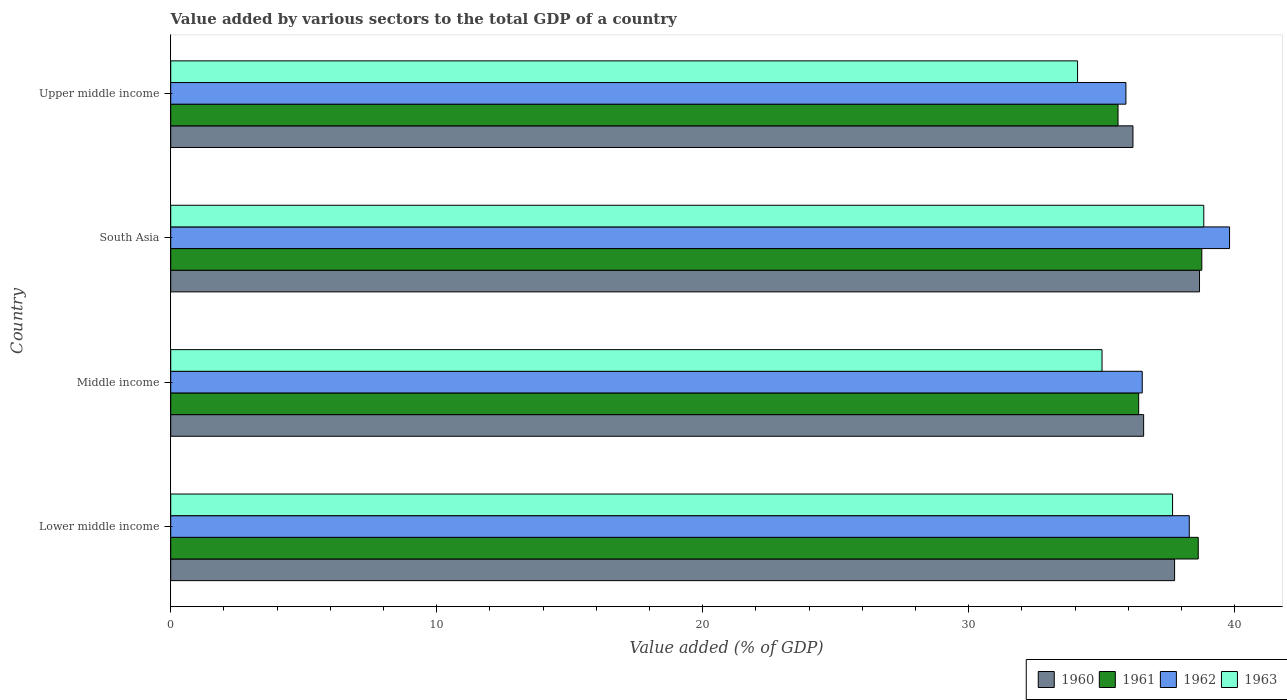How many different coloured bars are there?
Your answer should be very brief. 4. Are the number of bars per tick equal to the number of legend labels?
Your answer should be very brief. Yes. How many bars are there on the 1st tick from the bottom?
Your answer should be very brief. 4. What is the label of the 4th group of bars from the top?
Provide a short and direct response. Lower middle income. What is the value added by various sectors to the total GDP in 1961 in Upper middle income?
Keep it short and to the point. 35.61. Across all countries, what is the maximum value added by various sectors to the total GDP in 1960?
Offer a very short reply. 38.68. Across all countries, what is the minimum value added by various sectors to the total GDP in 1961?
Give a very brief answer. 35.61. In which country was the value added by various sectors to the total GDP in 1962 minimum?
Your response must be concise. Upper middle income. What is the total value added by various sectors to the total GDP in 1962 in the graph?
Your response must be concise. 150.53. What is the difference between the value added by various sectors to the total GDP in 1960 in Middle income and that in Upper middle income?
Provide a succinct answer. 0.4. What is the difference between the value added by various sectors to the total GDP in 1960 in Middle income and the value added by various sectors to the total GDP in 1962 in Upper middle income?
Ensure brevity in your answer.  0.67. What is the average value added by various sectors to the total GDP in 1961 per country?
Offer a terse response. 37.35. What is the difference between the value added by various sectors to the total GDP in 1961 and value added by various sectors to the total GDP in 1960 in Middle income?
Provide a short and direct response. -0.19. What is the ratio of the value added by various sectors to the total GDP in 1960 in Middle income to that in Upper middle income?
Ensure brevity in your answer.  1.01. Is the difference between the value added by various sectors to the total GDP in 1961 in Middle income and South Asia greater than the difference between the value added by various sectors to the total GDP in 1960 in Middle income and South Asia?
Your answer should be very brief. No. What is the difference between the highest and the second highest value added by various sectors to the total GDP in 1963?
Ensure brevity in your answer.  1.17. What is the difference between the highest and the lowest value added by various sectors to the total GDP in 1963?
Give a very brief answer. 4.74. In how many countries, is the value added by various sectors to the total GDP in 1962 greater than the average value added by various sectors to the total GDP in 1962 taken over all countries?
Offer a very short reply. 2. Is the sum of the value added by various sectors to the total GDP in 1963 in Lower middle income and Upper middle income greater than the maximum value added by various sectors to the total GDP in 1960 across all countries?
Provide a succinct answer. Yes. Is it the case that in every country, the sum of the value added by various sectors to the total GDP in 1963 and value added by various sectors to the total GDP in 1961 is greater than the sum of value added by various sectors to the total GDP in 1962 and value added by various sectors to the total GDP in 1960?
Provide a short and direct response. No. Are all the bars in the graph horizontal?
Your answer should be very brief. Yes. Does the graph contain any zero values?
Make the answer very short. No. Where does the legend appear in the graph?
Keep it short and to the point. Bottom right. How many legend labels are there?
Make the answer very short. 4. How are the legend labels stacked?
Ensure brevity in your answer.  Horizontal. What is the title of the graph?
Your answer should be very brief. Value added by various sectors to the total GDP of a country. Does "2009" appear as one of the legend labels in the graph?
Provide a succinct answer. No. What is the label or title of the X-axis?
Your answer should be very brief. Value added (% of GDP). What is the label or title of the Y-axis?
Your response must be concise. Country. What is the Value added (% of GDP) in 1960 in Lower middle income?
Offer a very short reply. 37.74. What is the Value added (% of GDP) in 1961 in Lower middle income?
Your answer should be very brief. 38.63. What is the Value added (% of GDP) of 1962 in Lower middle income?
Your answer should be very brief. 38.29. What is the Value added (% of GDP) in 1963 in Lower middle income?
Your response must be concise. 37.66. What is the Value added (% of GDP) in 1960 in Middle income?
Offer a terse response. 36.58. What is the Value added (% of GDP) of 1961 in Middle income?
Provide a succinct answer. 36.39. What is the Value added (% of GDP) of 1962 in Middle income?
Your response must be concise. 36.52. What is the Value added (% of GDP) of 1963 in Middle income?
Make the answer very short. 35.01. What is the Value added (% of GDP) in 1960 in South Asia?
Give a very brief answer. 38.68. What is the Value added (% of GDP) of 1961 in South Asia?
Your answer should be compact. 38.76. What is the Value added (% of GDP) in 1962 in South Asia?
Give a very brief answer. 39.81. What is the Value added (% of GDP) in 1963 in South Asia?
Offer a terse response. 38.84. What is the Value added (% of GDP) of 1960 in Upper middle income?
Give a very brief answer. 36.17. What is the Value added (% of GDP) of 1961 in Upper middle income?
Give a very brief answer. 35.61. What is the Value added (% of GDP) of 1962 in Upper middle income?
Your answer should be compact. 35.91. What is the Value added (% of GDP) of 1963 in Upper middle income?
Ensure brevity in your answer.  34.09. Across all countries, what is the maximum Value added (% of GDP) in 1960?
Your response must be concise. 38.68. Across all countries, what is the maximum Value added (% of GDP) in 1961?
Ensure brevity in your answer.  38.76. Across all countries, what is the maximum Value added (% of GDP) of 1962?
Provide a short and direct response. 39.81. Across all countries, what is the maximum Value added (% of GDP) of 1963?
Provide a short and direct response. 38.84. Across all countries, what is the minimum Value added (% of GDP) in 1960?
Keep it short and to the point. 36.17. Across all countries, what is the minimum Value added (% of GDP) of 1961?
Make the answer very short. 35.61. Across all countries, what is the minimum Value added (% of GDP) of 1962?
Provide a short and direct response. 35.91. Across all countries, what is the minimum Value added (% of GDP) of 1963?
Give a very brief answer. 34.09. What is the total Value added (% of GDP) of 1960 in the graph?
Keep it short and to the point. 149.17. What is the total Value added (% of GDP) in 1961 in the graph?
Make the answer very short. 149.39. What is the total Value added (% of GDP) of 1962 in the graph?
Provide a short and direct response. 150.53. What is the total Value added (% of GDP) of 1963 in the graph?
Give a very brief answer. 145.6. What is the difference between the Value added (% of GDP) in 1960 in Lower middle income and that in Middle income?
Make the answer very short. 1.16. What is the difference between the Value added (% of GDP) of 1961 in Lower middle income and that in Middle income?
Give a very brief answer. 2.24. What is the difference between the Value added (% of GDP) in 1962 in Lower middle income and that in Middle income?
Your answer should be very brief. 1.77. What is the difference between the Value added (% of GDP) of 1963 in Lower middle income and that in Middle income?
Offer a very short reply. 2.65. What is the difference between the Value added (% of GDP) in 1960 in Lower middle income and that in South Asia?
Offer a very short reply. -0.94. What is the difference between the Value added (% of GDP) of 1961 in Lower middle income and that in South Asia?
Provide a short and direct response. -0.13. What is the difference between the Value added (% of GDP) in 1962 in Lower middle income and that in South Asia?
Offer a terse response. -1.51. What is the difference between the Value added (% of GDP) in 1963 in Lower middle income and that in South Asia?
Offer a very short reply. -1.17. What is the difference between the Value added (% of GDP) of 1960 in Lower middle income and that in Upper middle income?
Offer a terse response. 1.57. What is the difference between the Value added (% of GDP) in 1961 in Lower middle income and that in Upper middle income?
Provide a succinct answer. 3.02. What is the difference between the Value added (% of GDP) in 1962 in Lower middle income and that in Upper middle income?
Give a very brief answer. 2.38. What is the difference between the Value added (% of GDP) of 1963 in Lower middle income and that in Upper middle income?
Your answer should be very brief. 3.57. What is the difference between the Value added (% of GDP) of 1960 in Middle income and that in South Asia?
Your answer should be very brief. -2.1. What is the difference between the Value added (% of GDP) in 1961 in Middle income and that in South Asia?
Keep it short and to the point. -2.37. What is the difference between the Value added (% of GDP) of 1962 in Middle income and that in South Asia?
Make the answer very short. -3.28. What is the difference between the Value added (% of GDP) in 1963 in Middle income and that in South Asia?
Your answer should be compact. -3.83. What is the difference between the Value added (% of GDP) in 1960 in Middle income and that in Upper middle income?
Ensure brevity in your answer.  0.4. What is the difference between the Value added (% of GDP) in 1961 in Middle income and that in Upper middle income?
Your response must be concise. 0.78. What is the difference between the Value added (% of GDP) in 1962 in Middle income and that in Upper middle income?
Keep it short and to the point. 0.61. What is the difference between the Value added (% of GDP) of 1963 in Middle income and that in Upper middle income?
Your response must be concise. 0.92. What is the difference between the Value added (% of GDP) in 1960 in South Asia and that in Upper middle income?
Make the answer very short. 2.5. What is the difference between the Value added (% of GDP) of 1961 in South Asia and that in Upper middle income?
Keep it short and to the point. 3.15. What is the difference between the Value added (% of GDP) of 1962 in South Asia and that in Upper middle income?
Your answer should be very brief. 3.9. What is the difference between the Value added (% of GDP) of 1963 in South Asia and that in Upper middle income?
Offer a terse response. 4.74. What is the difference between the Value added (% of GDP) of 1960 in Lower middle income and the Value added (% of GDP) of 1961 in Middle income?
Offer a very short reply. 1.35. What is the difference between the Value added (% of GDP) of 1960 in Lower middle income and the Value added (% of GDP) of 1962 in Middle income?
Provide a succinct answer. 1.22. What is the difference between the Value added (% of GDP) of 1960 in Lower middle income and the Value added (% of GDP) of 1963 in Middle income?
Give a very brief answer. 2.73. What is the difference between the Value added (% of GDP) in 1961 in Lower middle income and the Value added (% of GDP) in 1962 in Middle income?
Make the answer very short. 2.11. What is the difference between the Value added (% of GDP) of 1961 in Lower middle income and the Value added (% of GDP) of 1963 in Middle income?
Ensure brevity in your answer.  3.62. What is the difference between the Value added (% of GDP) in 1962 in Lower middle income and the Value added (% of GDP) in 1963 in Middle income?
Your answer should be very brief. 3.28. What is the difference between the Value added (% of GDP) of 1960 in Lower middle income and the Value added (% of GDP) of 1961 in South Asia?
Your answer should be compact. -1.02. What is the difference between the Value added (% of GDP) in 1960 in Lower middle income and the Value added (% of GDP) in 1962 in South Asia?
Give a very brief answer. -2.07. What is the difference between the Value added (% of GDP) in 1960 in Lower middle income and the Value added (% of GDP) in 1963 in South Asia?
Offer a very short reply. -1.1. What is the difference between the Value added (% of GDP) of 1961 in Lower middle income and the Value added (% of GDP) of 1962 in South Asia?
Offer a very short reply. -1.18. What is the difference between the Value added (% of GDP) in 1961 in Lower middle income and the Value added (% of GDP) in 1963 in South Asia?
Offer a terse response. -0.21. What is the difference between the Value added (% of GDP) in 1962 in Lower middle income and the Value added (% of GDP) in 1963 in South Asia?
Your response must be concise. -0.55. What is the difference between the Value added (% of GDP) of 1960 in Lower middle income and the Value added (% of GDP) of 1961 in Upper middle income?
Make the answer very short. 2.13. What is the difference between the Value added (% of GDP) of 1960 in Lower middle income and the Value added (% of GDP) of 1962 in Upper middle income?
Offer a very short reply. 1.83. What is the difference between the Value added (% of GDP) in 1960 in Lower middle income and the Value added (% of GDP) in 1963 in Upper middle income?
Your answer should be compact. 3.65. What is the difference between the Value added (% of GDP) in 1961 in Lower middle income and the Value added (% of GDP) in 1962 in Upper middle income?
Keep it short and to the point. 2.72. What is the difference between the Value added (% of GDP) of 1961 in Lower middle income and the Value added (% of GDP) of 1963 in Upper middle income?
Keep it short and to the point. 4.54. What is the difference between the Value added (% of GDP) of 1962 in Lower middle income and the Value added (% of GDP) of 1963 in Upper middle income?
Your answer should be very brief. 4.2. What is the difference between the Value added (% of GDP) in 1960 in Middle income and the Value added (% of GDP) in 1961 in South Asia?
Offer a very short reply. -2.19. What is the difference between the Value added (% of GDP) of 1960 in Middle income and the Value added (% of GDP) of 1962 in South Asia?
Your answer should be very brief. -3.23. What is the difference between the Value added (% of GDP) in 1960 in Middle income and the Value added (% of GDP) in 1963 in South Asia?
Make the answer very short. -2.26. What is the difference between the Value added (% of GDP) of 1961 in Middle income and the Value added (% of GDP) of 1962 in South Asia?
Offer a terse response. -3.42. What is the difference between the Value added (% of GDP) of 1961 in Middle income and the Value added (% of GDP) of 1963 in South Asia?
Offer a very short reply. -2.45. What is the difference between the Value added (% of GDP) in 1962 in Middle income and the Value added (% of GDP) in 1963 in South Asia?
Make the answer very short. -2.31. What is the difference between the Value added (% of GDP) of 1960 in Middle income and the Value added (% of GDP) of 1961 in Upper middle income?
Your answer should be compact. 0.96. What is the difference between the Value added (% of GDP) in 1960 in Middle income and the Value added (% of GDP) in 1962 in Upper middle income?
Provide a succinct answer. 0.67. What is the difference between the Value added (% of GDP) of 1960 in Middle income and the Value added (% of GDP) of 1963 in Upper middle income?
Make the answer very short. 2.48. What is the difference between the Value added (% of GDP) in 1961 in Middle income and the Value added (% of GDP) in 1962 in Upper middle income?
Keep it short and to the point. 0.48. What is the difference between the Value added (% of GDP) of 1961 in Middle income and the Value added (% of GDP) of 1963 in Upper middle income?
Your answer should be very brief. 2.3. What is the difference between the Value added (% of GDP) of 1962 in Middle income and the Value added (% of GDP) of 1963 in Upper middle income?
Your response must be concise. 2.43. What is the difference between the Value added (% of GDP) in 1960 in South Asia and the Value added (% of GDP) in 1961 in Upper middle income?
Your answer should be very brief. 3.06. What is the difference between the Value added (% of GDP) of 1960 in South Asia and the Value added (% of GDP) of 1962 in Upper middle income?
Your response must be concise. 2.77. What is the difference between the Value added (% of GDP) of 1960 in South Asia and the Value added (% of GDP) of 1963 in Upper middle income?
Provide a short and direct response. 4.58. What is the difference between the Value added (% of GDP) in 1961 in South Asia and the Value added (% of GDP) in 1962 in Upper middle income?
Ensure brevity in your answer.  2.85. What is the difference between the Value added (% of GDP) of 1961 in South Asia and the Value added (% of GDP) of 1963 in Upper middle income?
Your answer should be very brief. 4.67. What is the difference between the Value added (% of GDP) in 1962 in South Asia and the Value added (% of GDP) in 1963 in Upper middle income?
Keep it short and to the point. 5.71. What is the average Value added (% of GDP) of 1960 per country?
Offer a terse response. 37.29. What is the average Value added (% of GDP) of 1961 per country?
Keep it short and to the point. 37.35. What is the average Value added (% of GDP) of 1962 per country?
Make the answer very short. 37.63. What is the average Value added (% of GDP) of 1963 per country?
Keep it short and to the point. 36.4. What is the difference between the Value added (% of GDP) of 1960 and Value added (% of GDP) of 1961 in Lower middle income?
Make the answer very short. -0.89. What is the difference between the Value added (% of GDP) of 1960 and Value added (% of GDP) of 1962 in Lower middle income?
Your answer should be very brief. -0.55. What is the difference between the Value added (% of GDP) of 1960 and Value added (% of GDP) of 1963 in Lower middle income?
Keep it short and to the point. 0.08. What is the difference between the Value added (% of GDP) of 1961 and Value added (% of GDP) of 1962 in Lower middle income?
Provide a succinct answer. 0.34. What is the difference between the Value added (% of GDP) in 1961 and Value added (% of GDP) in 1963 in Lower middle income?
Your answer should be very brief. 0.97. What is the difference between the Value added (% of GDP) in 1962 and Value added (% of GDP) in 1963 in Lower middle income?
Keep it short and to the point. 0.63. What is the difference between the Value added (% of GDP) of 1960 and Value added (% of GDP) of 1961 in Middle income?
Your answer should be very brief. 0.19. What is the difference between the Value added (% of GDP) in 1960 and Value added (% of GDP) in 1962 in Middle income?
Provide a short and direct response. 0.05. What is the difference between the Value added (% of GDP) in 1960 and Value added (% of GDP) in 1963 in Middle income?
Ensure brevity in your answer.  1.56. What is the difference between the Value added (% of GDP) of 1961 and Value added (% of GDP) of 1962 in Middle income?
Provide a short and direct response. -0.13. What is the difference between the Value added (% of GDP) of 1961 and Value added (% of GDP) of 1963 in Middle income?
Provide a succinct answer. 1.38. What is the difference between the Value added (% of GDP) of 1962 and Value added (% of GDP) of 1963 in Middle income?
Make the answer very short. 1.51. What is the difference between the Value added (% of GDP) in 1960 and Value added (% of GDP) in 1961 in South Asia?
Make the answer very short. -0.09. What is the difference between the Value added (% of GDP) in 1960 and Value added (% of GDP) in 1962 in South Asia?
Provide a short and direct response. -1.13. What is the difference between the Value added (% of GDP) of 1960 and Value added (% of GDP) of 1963 in South Asia?
Offer a very short reply. -0.16. What is the difference between the Value added (% of GDP) of 1961 and Value added (% of GDP) of 1962 in South Asia?
Offer a very short reply. -1.04. What is the difference between the Value added (% of GDP) in 1961 and Value added (% of GDP) in 1963 in South Asia?
Offer a very short reply. -0.07. What is the difference between the Value added (% of GDP) in 1962 and Value added (% of GDP) in 1963 in South Asia?
Offer a terse response. 0.97. What is the difference between the Value added (% of GDP) of 1960 and Value added (% of GDP) of 1961 in Upper middle income?
Your response must be concise. 0.56. What is the difference between the Value added (% of GDP) in 1960 and Value added (% of GDP) in 1962 in Upper middle income?
Keep it short and to the point. 0.26. What is the difference between the Value added (% of GDP) in 1960 and Value added (% of GDP) in 1963 in Upper middle income?
Your answer should be very brief. 2.08. What is the difference between the Value added (% of GDP) of 1961 and Value added (% of GDP) of 1962 in Upper middle income?
Provide a succinct answer. -0.3. What is the difference between the Value added (% of GDP) in 1961 and Value added (% of GDP) in 1963 in Upper middle income?
Keep it short and to the point. 1.52. What is the difference between the Value added (% of GDP) of 1962 and Value added (% of GDP) of 1963 in Upper middle income?
Your response must be concise. 1.82. What is the ratio of the Value added (% of GDP) of 1960 in Lower middle income to that in Middle income?
Your response must be concise. 1.03. What is the ratio of the Value added (% of GDP) in 1961 in Lower middle income to that in Middle income?
Give a very brief answer. 1.06. What is the ratio of the Value added (% of GDP) in 1962 in Lower middle income to that in Middle income?
Offer a very short reply. 1.05. What is the ratio of the Value added (% of GDP) in 1963 in Lower middle income to that in Middle income?
Provide a short and direct response. 1.08. What is the ratio of the Value added (% of GDP) in 1960 in Lower middle income to that in South Asia?
Make the answer very short. 0.98. What is the ratio of the Value added (% of GDP) in 1961 in Lower middle income to that in South Asia?
Offer a terse response. 1. What is the ratio of the Value added (% of GDP) of 1963 in Lower middle income to that in South Asia?
Your answer should be very brief. 0.97. What is the ratio of the Value added (% of GDP) in 1960 in Lower middle income to that in Upper middle income?
Ensure brevity in your answer.  1.04. What is the ratio of the Value added (% of GDP) in 1961 in Lower middle income to that in Upper middle income?
Offer a very short reply. 1.08. What is the ratio of the Value added (% of GDP) of 1962 in Lower middle income to that in Upper middle income?
Give a very brief answer. 1.07. What is the ratio of the Value added (% of GDP) in 1963 in Lower middle income to that in Upper middle income?
Your response must be concise. 1.1. What is the ratio of the Value added (% of GDP) in 1960 in Middle income to that in South Asia?
Offer a terse response. 0.95. What is the ratio of the Value added (% of GDP) of 1961 in Middle income to that in South Asia?
Ensure brevity in your answer.  0.94. What is the ratio of the Value added (% of GDP) of 1962 in Middle income to that in South Asia?
Offer a very short reply. 0.92. What is the ratio of the Value added (% of GDP) in 1963 in Middle income to that in South Asia?
Your answer should be very brief. 0.9. What is the ratio of the Value added (% of GDP) of 1960 in Middle income to that in Upper middle income?
Make the answer very short. 1.01. What is the ratio of the Value added (% of GDP) in 1961 in Middle income to that in Upper middle income?
Make the answer very short. 1.02. What is the ratio of the Value added (% of GDP) of 1962 in Middle income to that in Upper middle income?
Your answer should be very brief. 1.02. What is the ratio of the Value added (% of GDP) in 1963 in Middle income to that in Upper middle income?
Your answer should be very brief. 1.03. What is the ratio of the Value added (% of GDP) in 1960 in South Asia to that in Upper middle income?
Your answer should be compact. 1.07. What is the ratio of the Value added (% of GDP) of 1961 in South Asia to that in Upper middle income?
Your answer should be very brief. 1.09. What is the ratio of the Value added (% of GDP) of 1962 in South Asia to that in Upper middle income?
Offer a very short reply. 1.11. What is the ratio of the Value added (% of GDP) of 1963 in South Asia to that in Upper middle income?
Keep it short and to the point. 1.14. What is the difference between the highest and the second highest Value added (% of GDP) of 1960?
Make the answer very short. 0.94. What is the difference between the highest and the second highest Value added (% of GDP) of 1961?
Provide a short and direct response. 0.13. What is the difference between the highest and the second highest Value added (% of GDP) in 1962?
Ensure brevity in your answer.  1.51. What is the difference between the highest and the second highest Value added (% of GDP) in 1963?
Offer a very short reply. 1.17. What is the difference between the highest and the lowest Value added (% of GDP) in 1960?
Provide a succinct answer. 2.5. What is the difference between the highest and the lowest Value added (% of GDP) in 1961?
Provide a succinct answer. 3.15. What is the difference between the highest and the lowest Value added (% of GDP) of 1962?
Your answer should be compact. 3.9. What is the difference between the highest and the lowest Value added (% of GDP) in 1963?
Give a very brief answer. 4.74. 